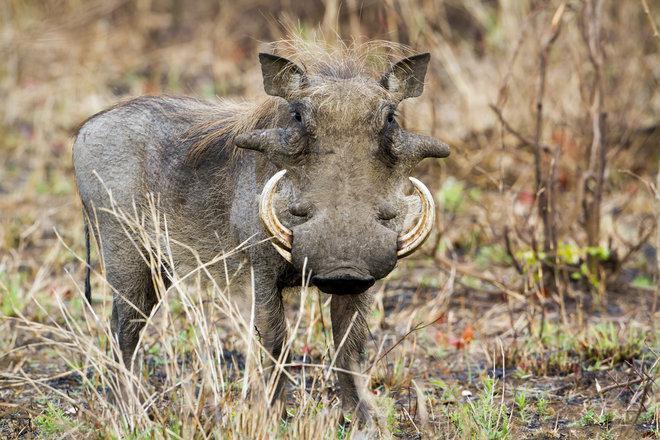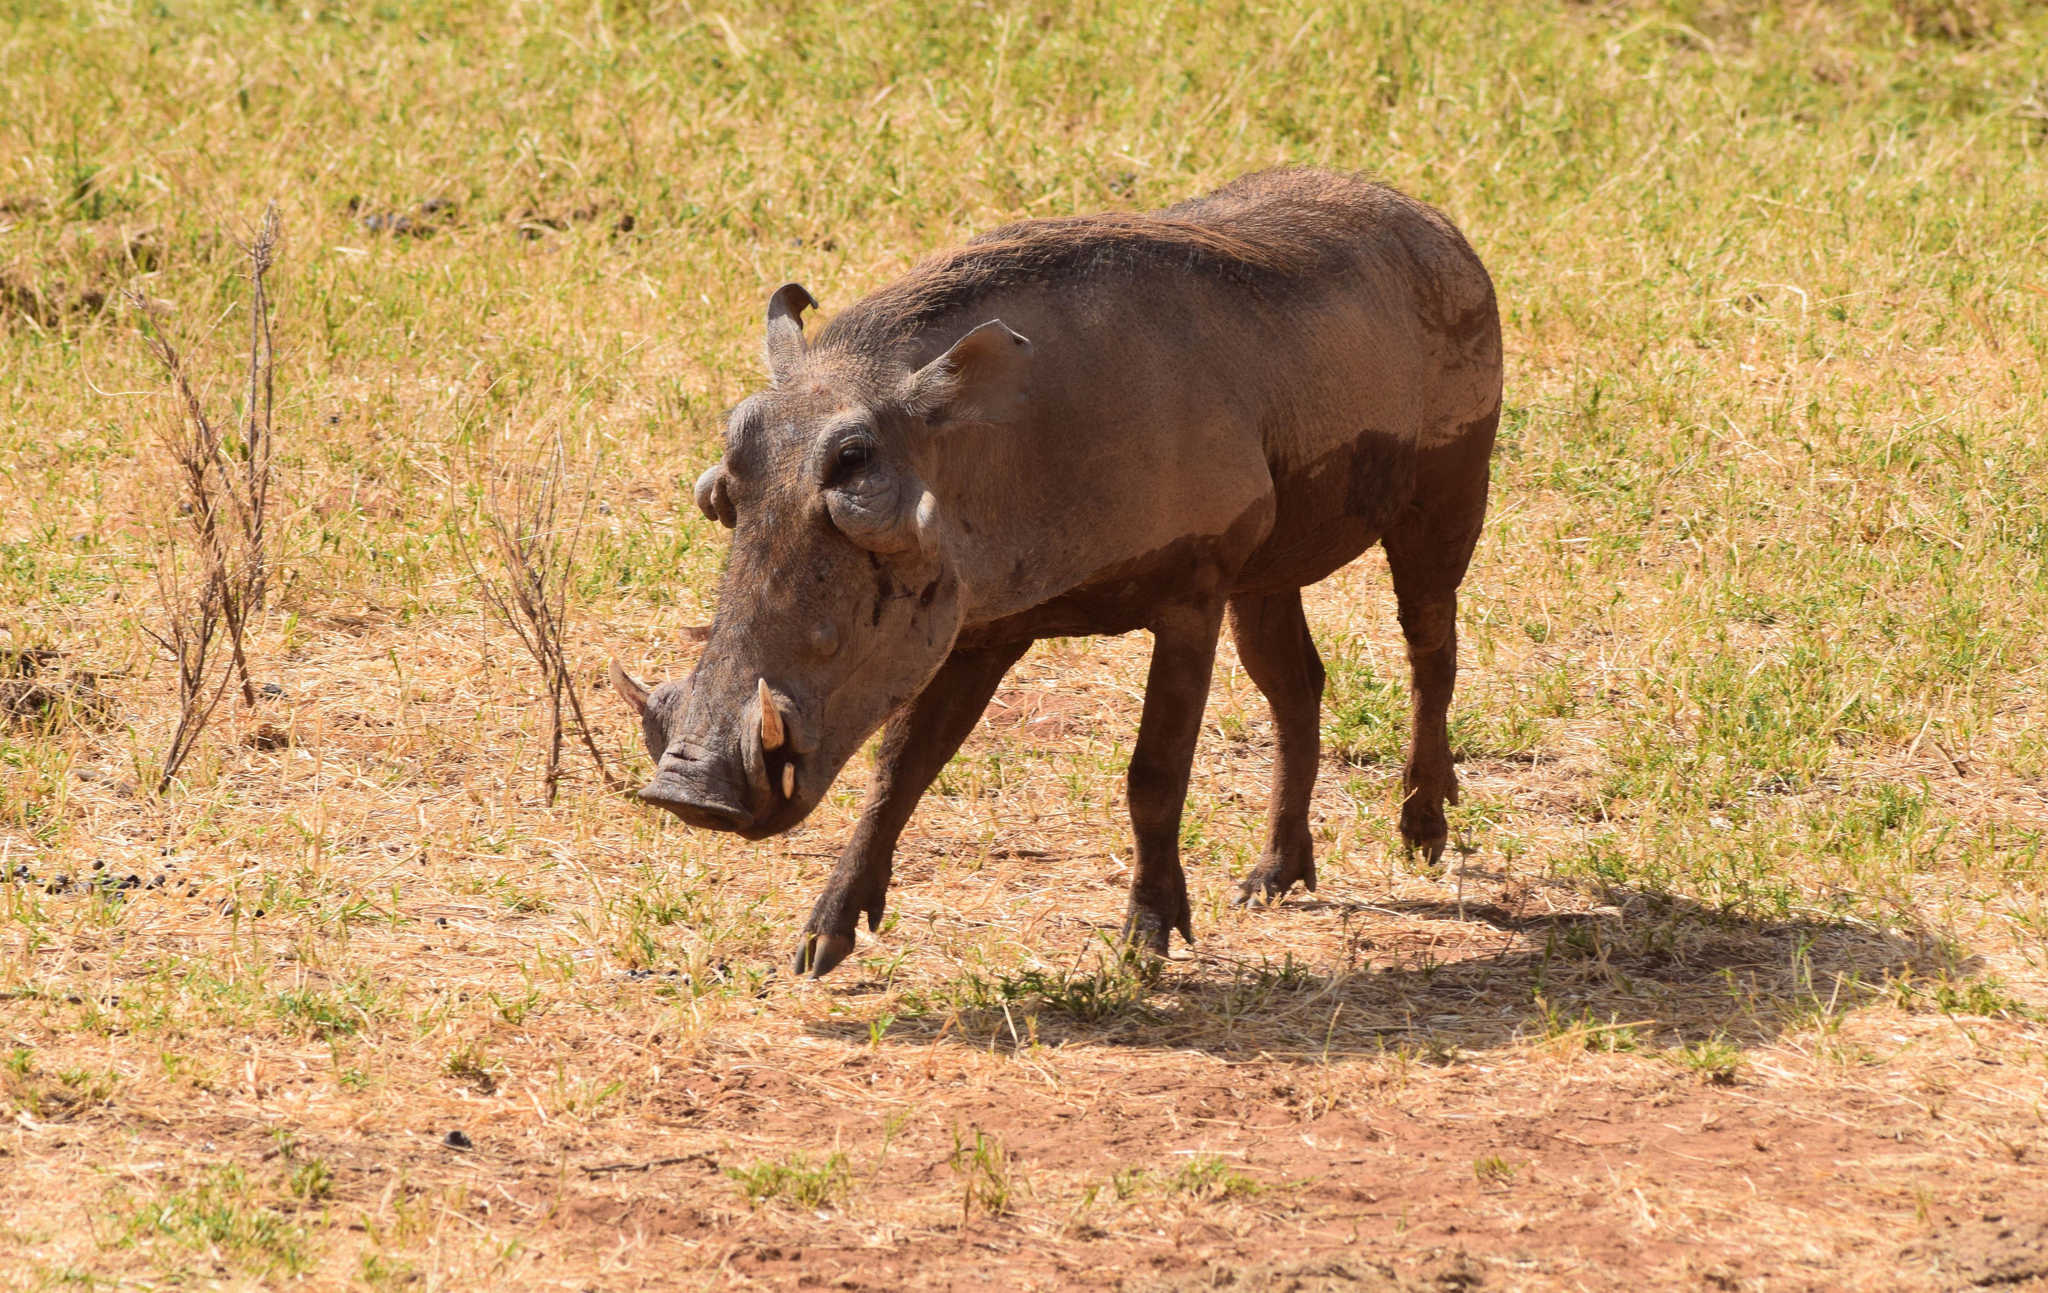The first image is the image on the left, the second image is the image on the right. For the images shown, is this caption "There are at least 4 animals." true? Answer yes or no. No. The first image is the image on the left, the second image is the image on the right. For the images shown, is this caption "All of the wild boars are alive and at least one other type of animal is also alive." true? Answer yes or no. No. 